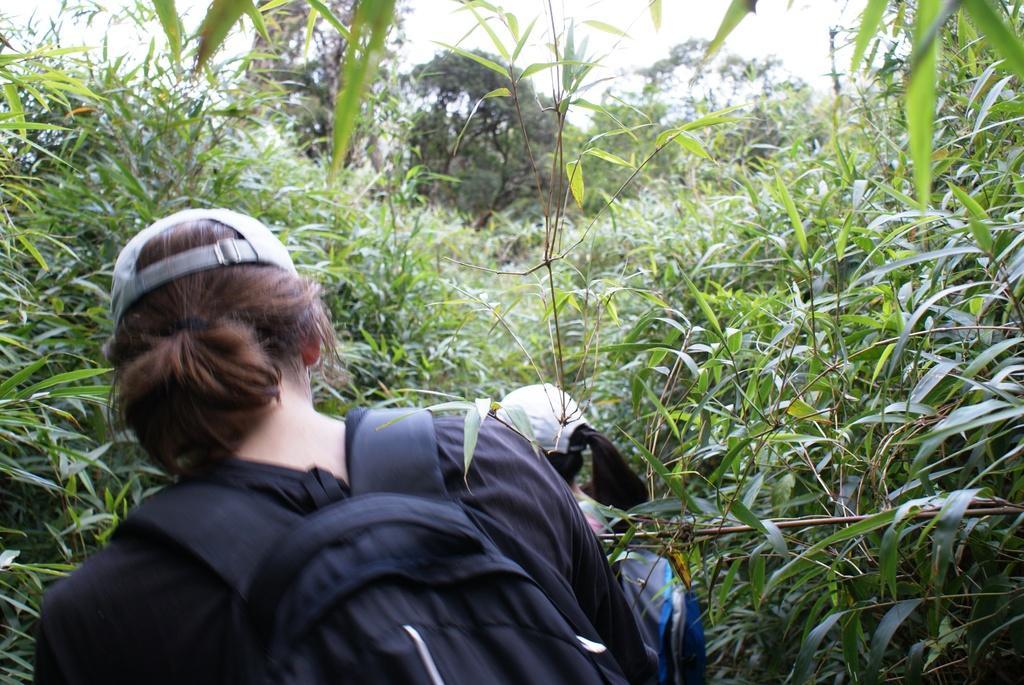Please provide a concise description of this image. In the picture we can see a woman walking in the bushes, she is with a bag and cap and in front of her we can see another woman walking and she is also with bag and cap and in the background we can see trees and part of the sky. 